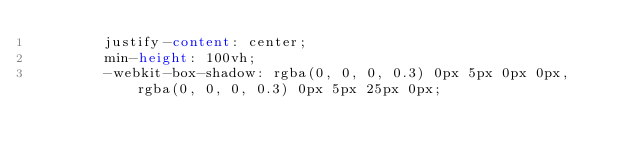<code> <loc_0><loc_0><loc_500><loc_500><_CSS_>        justify-content: center;
        min-height: 100vh;
        -webkit-box-shadow: rgba(0, 0, 0, 0.3) 0px 5px 0px 0px, rgba(0, 0, 0, 0.3) 0px 5px 25px 0px;</code> 